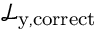<formula> <loc_0><loc_0><loc_500><loc_500>\mathcal { L } _ { y , c o r r e c t }</formula> 